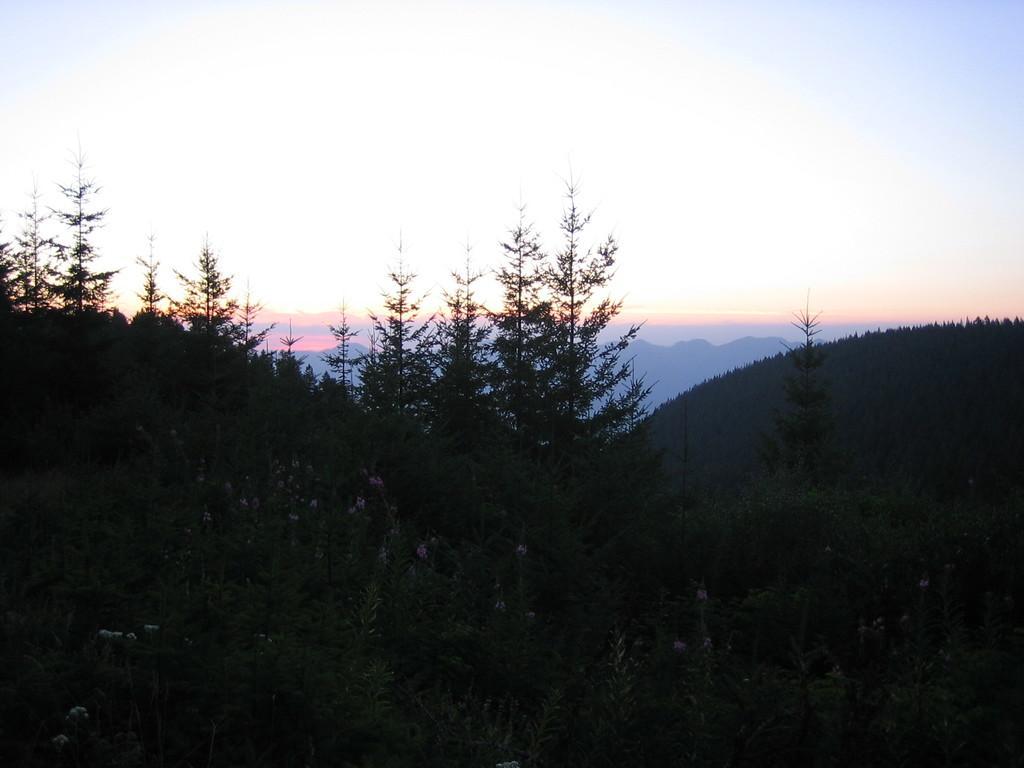Please provide a concise description of this image. This image is taken during the evening time. In this image we can see the hills, trees, plants and also the sky. 